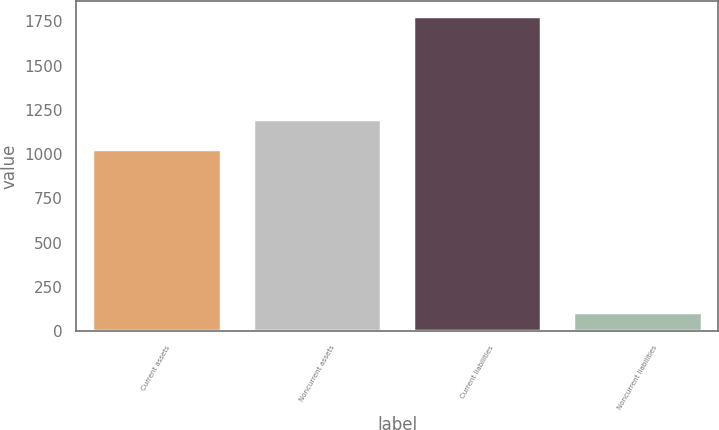<chart> <loc_0><loc_0><loc_500><loc_500><bar_chart><fcel>Current assets<fcel>Noncurrent assets<fcel>Current liabilities<fcel>Noncurrent liabilities<nl><fcel>1031.1<fcel>1197.97<fcel>1779<fcel>110.3<nl></chart> 